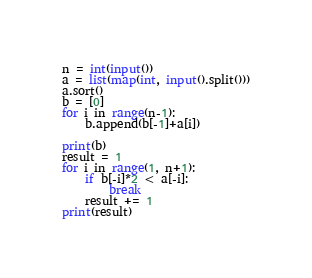Convert code to text. <code><loc_0><loc_0><loc_500><loc_500><_Python_>n = int(input())
a = list(map(int, input().split()))
a.sort()
b = [0]
for i in range(n-1):
    b.append(b[-1]+a[i])

print(b)
result = 1
for i in range(1, n+1):
    if b[-i]*2 < a[-i]:
        break
    result += 1
print(result)</code> 